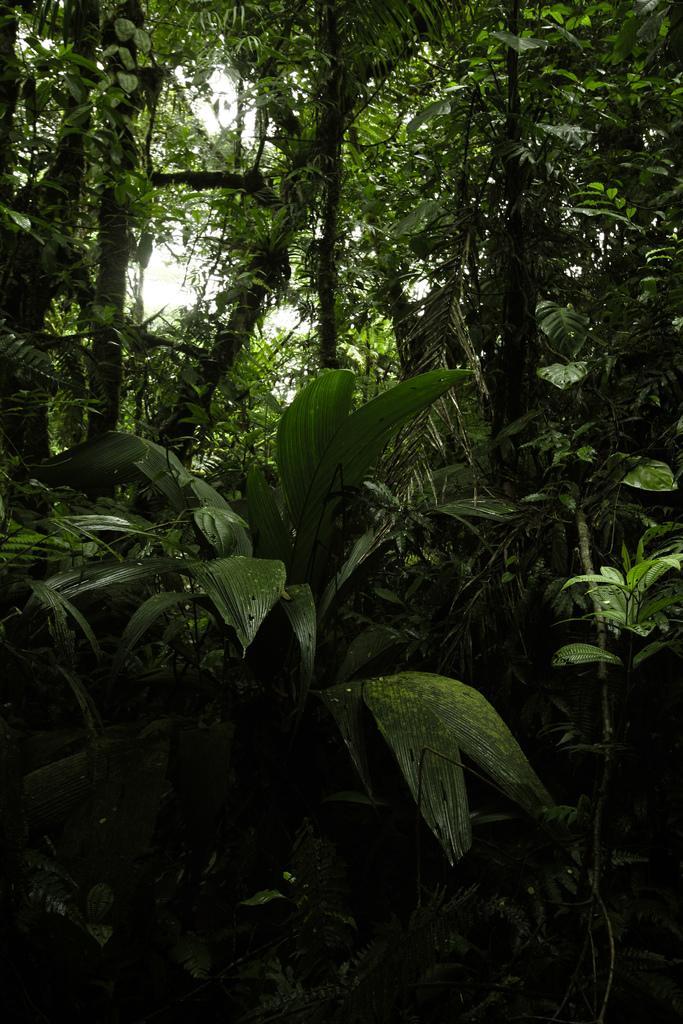Please provide a concise description of this image. In this image we can see group of plants ,trees and sky. 